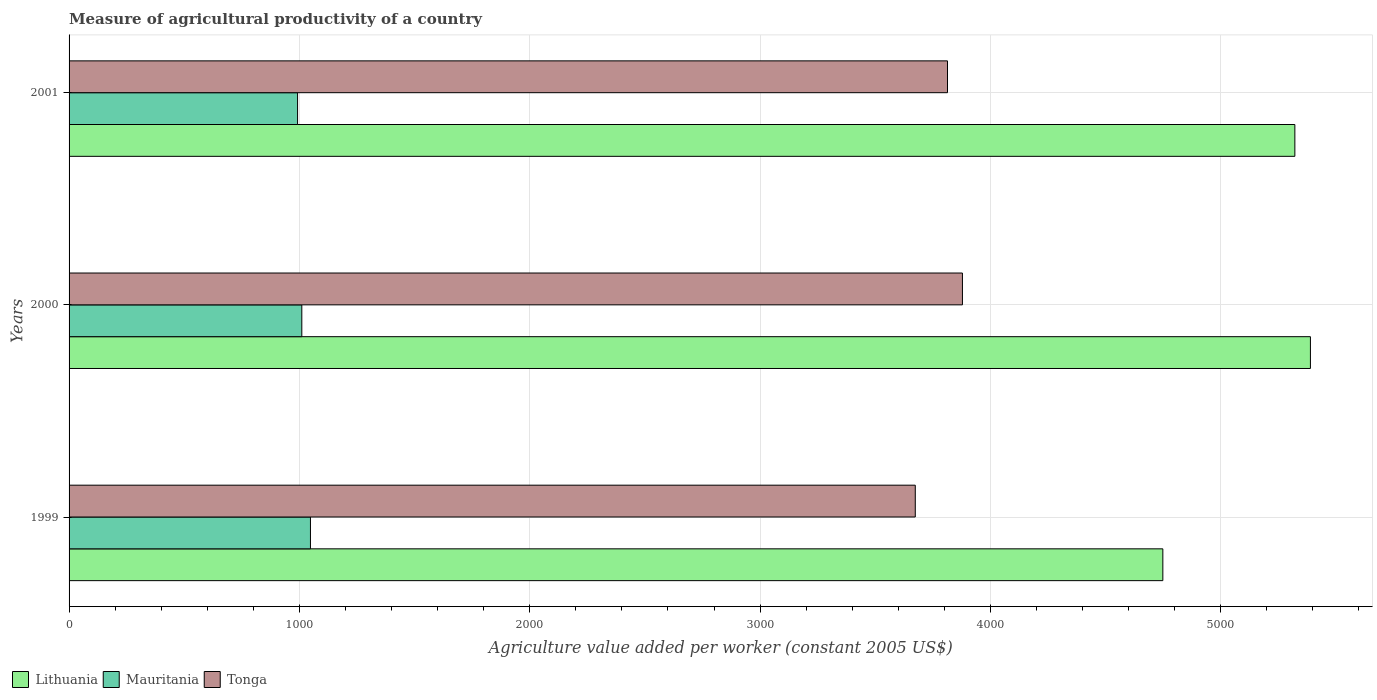How many bars are there on the 1st tick from the bottom?
Provide a succinct answer. 3. What is the measure of agricultural productivity in Mauritania in 2000?
Your response must be concise. 1010.49. Across all years, what is the maximum measure of agricultural productivity in Tonga?
Give a very brief answer. 3878.63. Across all years, what is the minimum measure of agricultural productivity in Tonga?
Provide a succinct answer. 3673.95. In which year was the measure of agricultural productivity in Lithuania maximum?
Your response must be concise. 2000. In which year was the measure of agricultural productivity in Lithuania minimum?
Your response must be concise. 1999. What is the total measure of agricultural productivity in Tonga in the graph?
Offer a very short reply. 1.14e+04. What is the difference between the measure of agricultural productivity in Lithuania in 2000 and that in 2001?
Keep it short and to the point. 67.57. What is the difference between the measure of agricultural productivity in Lithuania in 2001 and the measure of agricultural productivity in Tonga in 1999?
Keep it short and to the point. 1647.96. What is the average measure of agricultural productivity in Mauritania per year?
Your answer should be compact. 1016.86. In the year 2000, what is the difference between the measure of agricultural productivity in Tonga and measure of agricultural productivity in Mauritania?
Offer a terse response. 2868.14. In how many years, is the measure of agricultural productivity in Lithuania greater than 3400 US$?
Offer a very short reply. 3. What is the ratio of the measure of agricultural productivity in Mauritania in 2000 to that in 2001?
Offer a very short reply. 1.02. Is the measure of agricultural productivity in Tonga in 2000 less than that in 2001?
Your response must be concise. No. Is the difference between the measure of agricultural productivity in Tonga in 1999 and 2000 greater than the difference between the measure of agricultural productivity in Mauritania in 1999 and 2000?
Ensure brevity in your answer.  No. What is the difference between the highest and the second highest measure of agricultural productivity in Tonga?
Ensure brevity in your answer.  64.86. What is the difference between the highest and the lowest measure of agricultural productivity in Lithuania?
Your answer should be compact. 640.71. In how many years, is the measure of agricultural productivity in Lithuania greater than the average measure of agricultural productivity in Lithuania taken over all years?
Ensure brevity in your answer.  2. Is the sum of the measure of agricultural productivity in Mauritania in 1999 and 2000 greater than the maximum measure of agricultural productivity in Tonga across all years?
Give a very brief answer. No. What does the 2nd bar from the top in 1999 represents?
Make the answer very short. Mauritania. What does the 1st bar from the bottom in 1999 represents?
Provide a succinct answer. Lithuania. How many years are there in the graph?
Your response must be concise. 3. Are the values on the major ticks of X-axis written in scientific E-notation?
Offer a very short reply. No. Does the graph contain grids?
Your answer should be very brief. Yes. Where does the legend appear in the graph?
Offer a terse response. Bottom left. How many legend labels are there?
Give a very brief answer. 3. How are the legend labels stacked?
Provide a short and direct response. Horizontal. What is the title of the graph?
Your answer should be very brief. Measure of agricultural productivity of a country. What is the label or title of the X-axis?
Provide a succinct answer. Agriculture value added per worker (constant 2005 US$). What is the label or title of the Y-axis?
Give a very brief answer. Years. What is the Agriculture value added per worker (constant 2005 US$) in Lithuania in 1999?
Keep it short and to the point. 4748.77. What is the Agriculture value added per worker (constant 2005 US$) of Mauritania in 1999?
Your response must be concise. 1048. What is the Agriculture value added per worker (constant 2005 US$) in Tonga in 1999?
Give a very brief answer. 3673.95. What is the Agriculture value added per worker (constant 2005 US$) in Lithuania in 2000?
Make the answer very short. 5389.48. What is the Agriculture value added per worker (constant 2005 US$) of Mauritania in 2000?
Keep it short and to the point. 1010.49. What is the Agriculture value added per worker (constant 2005 US$) of Tonga in 2000?
Provide a succinct answer. 3878.63. What is the Agriculture value added per worker (constant 2005 US$) of Lithuania in 2001?
Your answer should be compact. 5321.91. What is the Agriculture value added per worker (constant 2005 US$) in Mauritania in 2001?
Ensure brevity in your answer.  992.1. What is the Agriculture value added per worker (constant 2005 US$) of Tonga in 2001?
Provide a short and direct response. 3813.77. Across all years, what is the maximum Agriculture value added per worker (constant 2005 US$) in Lithuania?
Offer a terse response. 5389.48. Across all years, what is the maximum Agriculture value added per worker (constant 2005 US$) of Mauritania?
Give a very brief answer. 1048. Across all years, what is the maximum Agriculture value added per worker (constant 2005 US$) of Tonga?
Keep it short and to the point. 3878.63. Across all years, what is the minimum Agriculture value added per worker (constant 2005 US$) of Lithuania?
Provide a short and direct response. 4748.77. Across all years, what is the minimum Agriculture value added per worker (constant 2005 US$) of Mauritania?
Your answer should be very brief. 992.1. Across all years, what is the minimum Agriculture value added per worker (constant 2005 US$) of Tonga?
Offer a terse response. 3673.95. What is the total Agriculture value added per worker (constant 2005 US$) in Lithuania in the graph?
Offer a very short reply. 1.55e+04. What is the total Agriculture value added per worker (constant 2005 US$) of Mauritania in the graph?
Provide a short and direct response. 3050.59. What is the total Agriculture value added per worker (constant 2005 US$) in Tonga in the graph?
Offer a very short reply. 1.14e+04. What is the difference between the Agriculture value added per worker (constant 2005 US$) in Lithuania in 1999 and that in 2000?
Provide a succinct answer. -640.71. What is the difference between the Agriculture value added per worker (constant 2005 US$) in Mauritania in 1999 and that in 2000?
Ensure brevity in your answer.  37.52. What is the difference between the Agriculture value added per worker (constant 2005 US$) in Tonga in 1999 and that in 2000?
Your answer should be very brief. -204.68. What is the difference between the Agriculture value added per worker (constant 2005 US$) of Lithuania in 1999 and that in 2001?
Ensure brevity in your answer.  -573.14. What is the difference between the Agriculture value added per worker (constant 2005 US$) of Mauritania in 1999 and that in 2001?
Your answer should be compact. 55.91. What is the difference between the Agriculture value added per worker (constant 2005 US$) of Tonga in 1999 and that in 2001?
Give a very brief answer. -139.82. What is the difference between the Agriculture value added per worker (constant 2005 US$) in Lithuania in 2000 and that in 2001?
Make the answer very short. 67.57. What is the difference between the Agriculture value added per worker (constant 2005 US$) of Mauritania in 2000 and that in 2001?
Your answer should be very brief. 18.39. What is the difference between the Agriculture value added per worker (constant 2005 US$) in Tonga in 2000 and that in 2001?
Provide a succinct answer. 64.86. What is the difference between the Agriculture value added per worker (constant 2005 US$) of Lithuania in 1999 and the Agriculture value added per worker (constant 2005 US$) of Mauritania in 2000?
Provide a succinct answer. 3738.28. What is the difference between the Agriculture value added per worker (constant 2005 US$) in Lithuania in 1999 and the Agriculture value added per worker (constant 2005 US$) in Tonga in 2000?
Keep it short and to the point. 870.14. What is the difference between the Agriculture value added per worker (constant 2005 US$) in Mauritania in 1999 and the Agriculture value added per worker (constant 2005 US$) in Tonga in 2000?
Your response must be concise. -2830.62. What is the difference between the Agriculture value added per worker (constant 2005 US$) in Lithuania in 1999 and the Agriculture value added per worker (constant 2005 US$) in Mauritania in 2001?
Give a very brief answer. 3756.67. What is the difference between the Agriculture value added per worker (constant 2005 US$) of Lithuania in 1999 and the Agriculture value added per worker (constant 2005 US$) of Tonga in 2001?
Offer a very short reply. 935. What is the difference between the Agriculture value added per worker (constant 2005 US$) of Mauritania in 1999 and the Agriculture value added per worker (constant 2005 US$) of Tonga in 2001?
Keep it short and to the point. -2765.77. What is the difference between the Agriculture value added per worker (constant 2005 US$) of Lithuania in 2000 and the Agriculture value added per worker (constant 2005 US$) of Mauritania in 2001?
Your answer should be compact. 4397.38. What is the difference between the Agriculture value added per worker (constant 2005 US$) in Lithuania in 2000 and the Agriculture value added per worker (constant 2005 US$) in Tonga in 2001?
Offer a terse response. 1575.7. What is the difference between the Agriculture value added per worker (constant 2005 US$) of Mauritania in 2000 and the Agriculture value added per worker (constant 2005 US$) of Tonga in 2001?
Your response must be concise. -2803.29. What is the average Agriculture value added per worker (constant 2005 US$) in Lithuania per year?
Your response must be concise. 5153.38. What is the average Agriculture value added per worker (constant 2005 US$) in Mauritania per year?
Ensure brevity in your answer.  1016.86. What is the average Agriculture value added per worker (constant 2005 US$) of Tonga per year?
Make the answer very short. 3788.78. In the year 1999, what is the difference between the Agriculture value added per worker (constant 2005 US$) of Lithuania and Agriculture value added per worker (constant 2005 US$) of Mauritania?
Provide a succinct answer. 3700.76. In the year 1999, what is the difference between the Agriculture value added per worker (constant 2005 US$) of Lithuania and Agriculture value added per worker (constant 2005 US$) of Tonga?
Keep it short and to the point. 1074.82. In the year 1999, what is the difference between the Agriculture value added per worker (constant 2005 US$) of Mauritania and Agriculture value added per worker (constant 2005 US$) of Tonga?
Offer a very short reply. -2625.94. In the year 2000, what is the difference between the Agriculture value added per worker (constant 2005 US$) in Lithuania and Agriculture value added per worker (constant 2005 US$) in Mauritania?
Offer a very short reply. 4378.99. In the year 2000, what is the difference between the Agriculture value added per worker (constant 2005 US$) in Lithuania and Agriculture value added per worker (constant 2005 US$) in Tonga?
Provide a succinct answer. 1510.85. In the year 2000, what is the difference between the Agriculture value added per worker (constant 2005 US$) of Mauritania and Agriculture value added per worker (constant 2005 US$) of Tonga?
Keep it short and to the point. -2868.14. In the year 2001, what is the difference between the Agriculture value added per worker (constant 2005 US$) in Lithuania and Agriculture value added per worker (constant 2005 US$) in Mauritania?
Ensure brevity in your answer.  4329.81. In the year 2001, what is the difference between the Agriculture value added per worker (constant 2005 US$) of Lithuania and Agriculture value added per worker (constant 2005 US$) of Tonga?
Your response must be concise. 1508.14. In the year 2001, what is the difference between the Agriculture value added per worker (constant 2005 US$) of Mauritania and Agriculture value added per worker (constant 2005 US$) of Tonga?
Make the answer very short. -2821.67. What is the ratio of the Agriculture value added per worker (constant 2005 US$) of Lithuania in 1999 to that in 2000?
Provide a succinct answer. 0.88. What is the ratio of the Agriculture value added per worker (constant 2005 US$) in Mauritania in 1999 to that in 2000?
Your answer should be compact. 1.04. What is the ratio of the Agriculture value added per worker (constant 2005 US$) in Tonga in 1999 to that in 2000?
Provide a short and direct response. 0.95. What is the ratio of the Agriculture value added per worker (constant 2005 US$) in Lithuania in 1999 to that in 2001?
Provide a short and direct response. 0.89. What is the ratio of the Agriculture value added per worker (constant 2005 US$) of Mauritania in 1999 to that in 2001?
Your answer should be very brief. 1.06. What is the ratio of the Agriculture value added per worker (constant 2005 US$) of Tonga in 1999 to that in 2001?
Offer a terse response. 0.96. What is the ratio of the Agriculture value added per worker (constant 2005 US$) in Lithuania in 2000 to that in 2001?
Provide a short and direct response. 1.01. What is the ratio of the Agriculture value added per worker (constant 2005 US$) of Mauritania in 2000 to that in 2001?
Give a very brief answer. 1.02. What is the ratio of the Agriculture value added per worker (constant 2005 US$) of Tonga in 2000 to that in 2001?
Your answer should be very brief. 1.02. What is the difference between the highest and the second highest Agriculture value added per worker (constant 2005 US$) in Lithuania?
Your response must be concise. 67.57. What is the difference between the highest and the second highest Agriculture value added per worker (constant 2005 US$) in Mauritania?
Offer a terse response. 37.52. What is the difference between the highest and the second highest Agriculture value added per worker (constant 2005 US$) of Tonga?
Make the answer very short. 64.86. What is the difference between the highest and the lowest Agriculture value added per worker (constant 2005 US$) of Lithuania?
Make the answer very short. 640.71. What is the difference between the highest and the lowest Agriculture value added per worker (constant 2005 US$) in Mauritania?
Give a very brief answer. 55.91. What is the difference between the highest and the lowest Agriculture value added per worker (constant 2005 US$) of Tonga?
Provide a succinct answer. 204.68. 